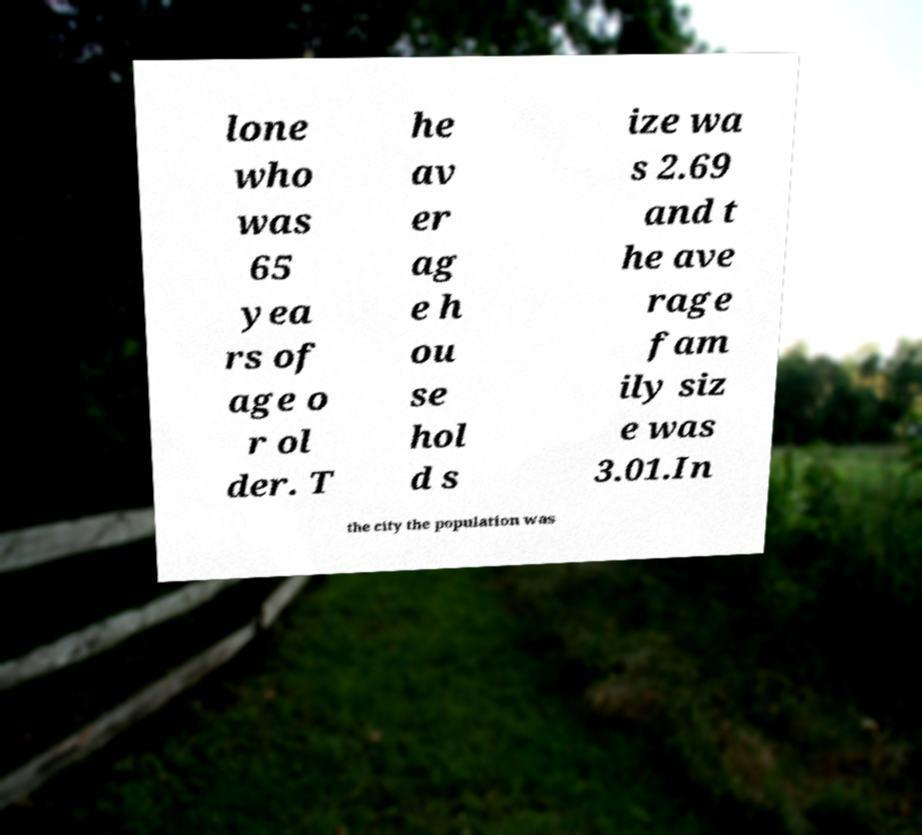Please identify and transcribe the text found in this image. lone who was 65 yea rs of age o r ol der. T he av er ag e h ou se hol d s ize wa s 2.69 and t he ave rage fam ily siz e was 3.01.In the city the population was 